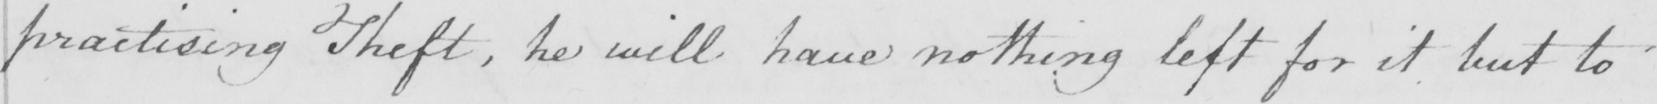Please transcribe the handwritten text in this image. practising Theft , he will have nothing left for it but to 